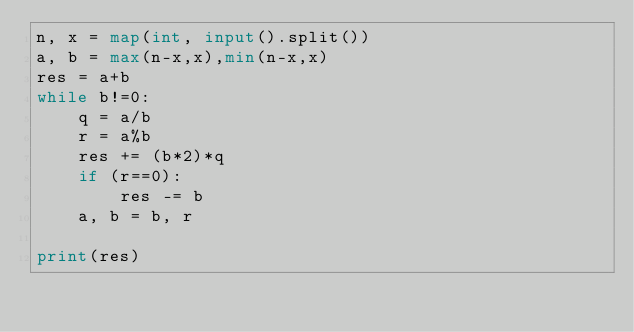<code> <loc_0><loc_0><loc_500><loc_500><_Python_>n, x = map(int, input().split())
a, b = max(n-x,x),min(n-x,x)
res = a+b
while b!=0:
    q = a/b
    r = a%b
    res += (b*2)*q
    if (r==0):
        res -= b
    a, b = b, r

print(res)</code> 